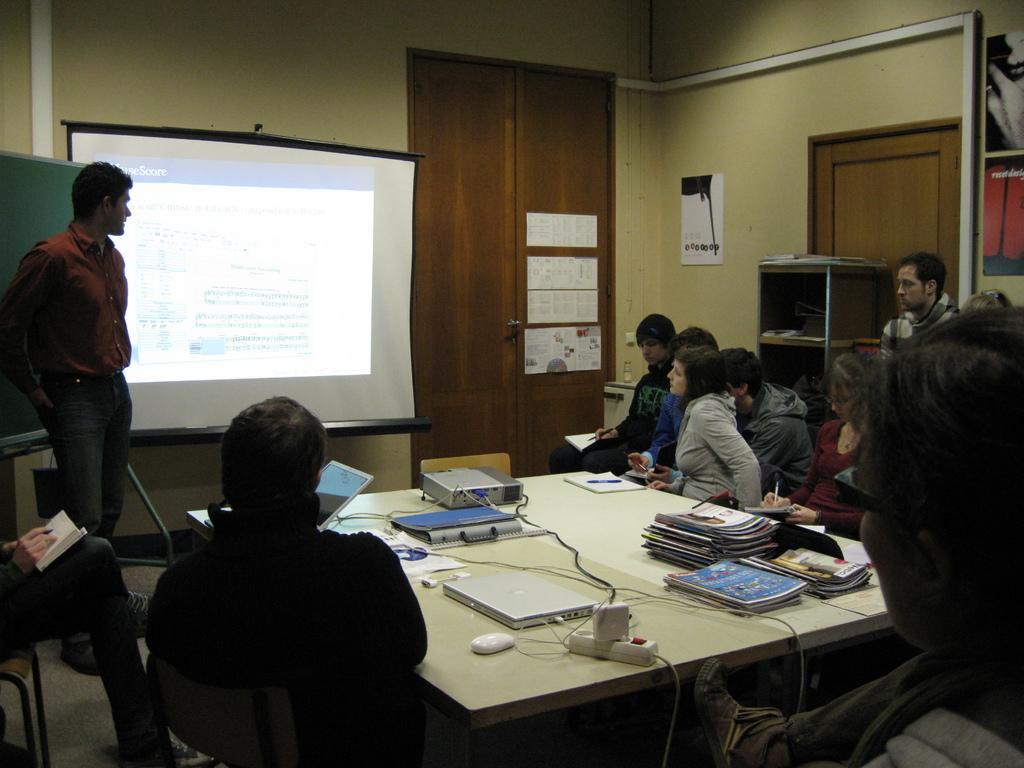Please provide a concise description of this image. In this image there are persons standing and sitting. In the center there is a table, on the table there are books, there is a laptop, there is a mouse, and there is wire, adapter, files. On the right side there is a door and in the center there is a screen on the wall, on the right side of the screen there is a door, on the door there are posters. On the left side there is a green colour board and in front of the board there is a man standing. 